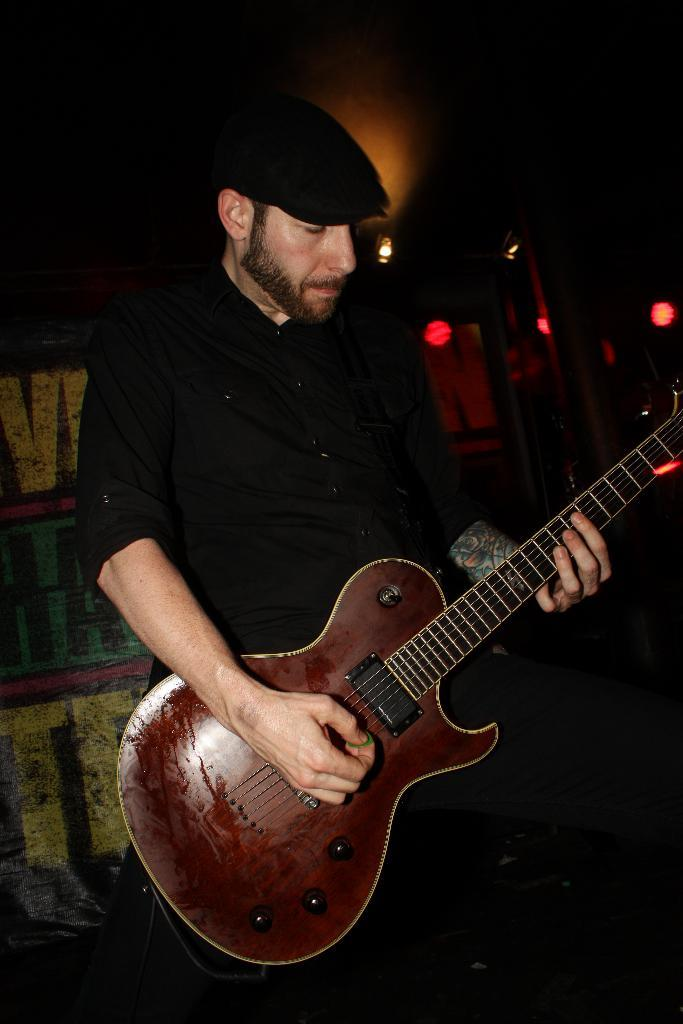What is the man in the image holding? The man is holding a guitar. What is the man wearing on his head? The man is wearing a cap. What is the man doing with the guitar? The man is playing the guitar. What can be seen in the background of the image? There are lights and a wall in the background of the image. What type of sweater is the man wearing in the image? The man is not wearing a sweater in the image; he is wearing a cap. How many lights can be seen in the image? The number of lights cannot be determined from the image, only that there are lights present in the background. 